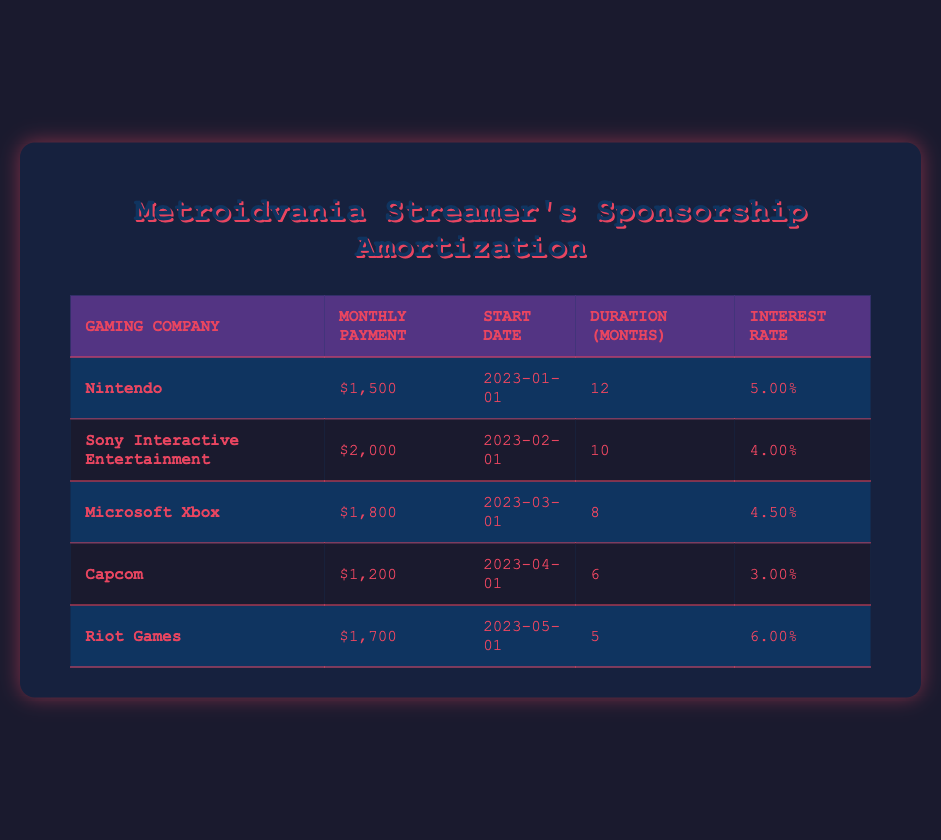What is the monthly payment from Riot Games? The table shows that the monthly payment for Riot Games is listed under the "Monthly Payment" column. Looking at the row for Riot Games, the value is $1,700.
Answer: 1700 Which gaming company has the highest monthly payment? By comparing the values in the "Monthly Payment" column, I see that the highest monthly payment is $2,000 from Sony Interactive Entertainment, which is the maximum among all companies.
Answer: Sony Interactive Entertainment What is the total duration of payments for Nintendo and Capcom combined? To find the combined duration, I look at the "Duration (Months)" column for both Nintendo and Capcom. Nintendo has a duration of 12 months, and Capcom has 6 months. Adding these values gives 12 + 6 = 18 months.
Answer: 18 Is the interest rate for Microsoft Xbox higher than that for Capcom? The interest rate for Microsoft Xbox is 4.5% and for Capcom it is 3.0%. Comparing these two, 4.5% is indeed higher than 3.0%, so the statement is true.
Answer: Yes What is the average monthly payment of all the gaming companies listed? To calculate the average, I sum all the monthly payments: 1500 + 2000 + 1800 + 1200 + 1700 = 10200. There are 5 companies, so the average is 10200 / 5 = 2040.
Answer: 2040 Which company has the shortest payment duration and what is that duration? I look at the "Duration (Months)" column to find the shortest duration. Capcom has a payment duration of 6 months, which is the least among all companies.
Answer: 6 Is there any company with an interest rate of 6%? I check the "Interest Rate" column for each company. The table shows that Riot Games has an interest rate of 6.0%, confirming the presence of such a rate.
Answer: Yes How much in total will be paid to Sony Interactive Entertainment over the entire duration? I calculate the total payment for Sony Interactive Entertainment by multiplying the monthly payment of $2,000 by its duration of 10 months. So, 2000 * 10 = 20000.
Answer: 20000 